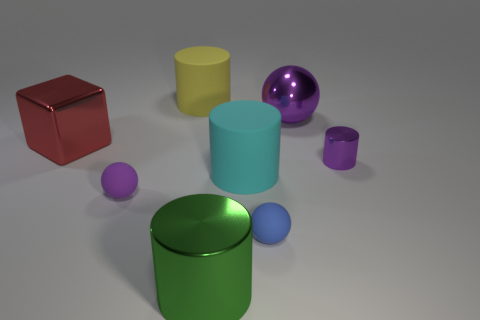Is there a small red object that has the same shape as the green object?
Give a very brief answer. No. Are there fewer big green metallic things than tiny blue shiny things?
Provide a short and direct response. No. Do the big green shiny thing and the big purple metallic thing have the same shape?
Offer a very short reply. No. What number of things are cyan shiny things or small rubber spheres that are left of the cyan cylinder?
Make the answer very short. 1. What number of big things are there?
Your response must be concise. 5. Are there any purple metallic things of the same size as the purple rubber ball?
Your answer should be compact. Yes. Are there fewer small rubber balls behind the big shiny sphere than small cyan matte blocks?
Make the answer very short. No. Is the size of the cyan matte cylinder the same as the purple matte thing?
Provide a succinct answer. No. What size is the ball that is made of the same material as the red object?
Ensure brevity in your answer.  Large. How many matte cylinders are the same color as the tiny metallic cylinder?
Offer a very short reply. 0. 